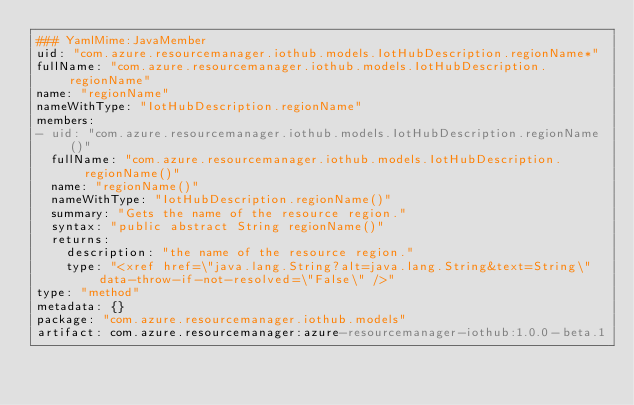<code> <loc_0><loc_0><loc_500><loc_500><_YAML_>### YamlMime:JavaMember
uid: "com.azure.resourcemanager.iothub.models.IotHubDescription.regionName*"
fullName: "com.azure.resourcemanager.iothub.models.IotHubDescription.regionName"
name: "regionName"
nameWithType: "IotHubDescription.regionName"
members:
- uid: "com.azure.resourcemanager.iothub.models.IotHubDescription.regionName()"
  fullName: "com.azure.resourcemanager.iothub.models.IotHubDescription.regionName()"
  name: "regionName()"
  nameWithType: "IotHubDescription.regionName()"
  summary: "Gets the name of the resource region."
  syntax: "public abstract String regionName()"
  returns:
    description: "the name of the resource region."
    type: "<xref href=\"java.lang.String?alt=java.lang.String&text=String\" data-throw-if-not-resolved=\"False\" />"
type: "method"
metadata: {}
package: "com.azure.resourcemanager.iothub.models"
artifact: com.azure.resourcemanager:azure-resourcemanager-iothub:1.0.0-beta.1
</code> 